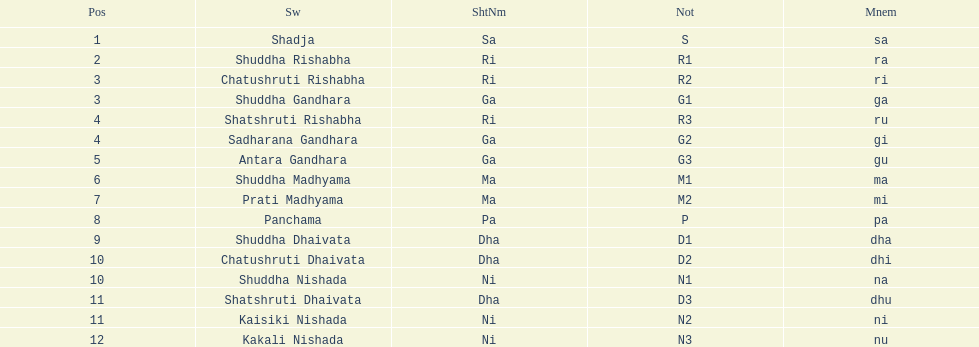Write the full table. {'header': ['Pos', 'Sw', 'ShtNm', 'Not', 'Mnem'], 'rows': [['1', 'Shadja', 'Sa', 'S', 'sa'], ['2', 'Shuddha Rishabha', 'Ri', 'R1', 'ra'], ['3', 'Chatushruti Rishabha', 'Ri', 'R2', 'ri'], ['3', 'Shuddha Gandhara', 'Ga', 'G1', 'ga'], ['4', 'Shatshruti Rishabha', 'Ri', 'R3', 'ru'], ['4', 'Sadharana Gandhara', 'Ga', 'G2', 'gi'], ['5', 'Antara Gandhara', 'Ga', 'G3', 'gu'], ['6', 'Shuddha Madhyama', 'Ma', 'M1', 'ma'], ['7', 'Prati Madhyama', 'Ma', 'M2', 'mi'], ['8', 'Panchama', 'Pa', 'P', 'pa'], ['9', 'Shuddha Dhaivata', 'Dha', 'D1', 'dha'], ['10', 'Chatushruti Dhaivata', 'Dha', 'D2', 'dhi'], ['10', 'Shuddha Nishada', 'Ni', 'N1', 'na'], ['11', 'Shatshruti Dhaivata', 'Dha', 'D3', 'dhu'], ['11', 'Kaisiki Nishada', 'Ni', 'N2', 'ni'], ['12', 'Kakali Nishada', 'Ni', 'N3', 'nu']]} Besides m1, how many notations include "1" in them? 4. 